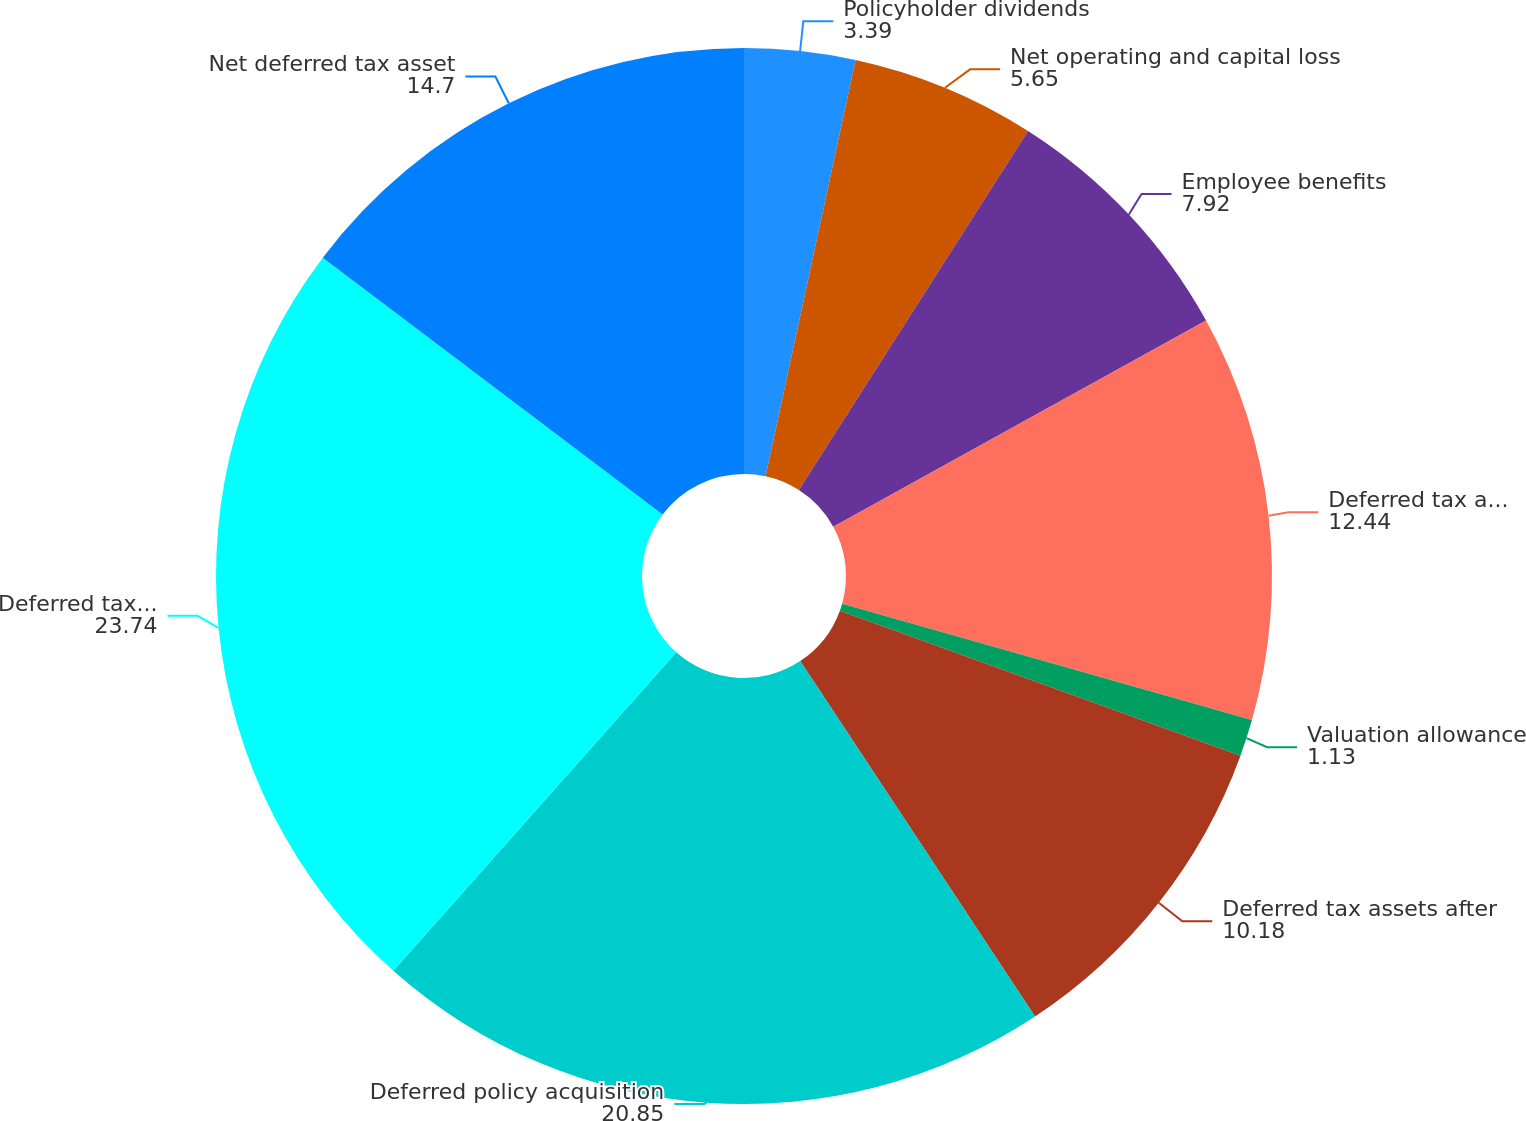Convert chart to OTSL. <chart><loc_0><loc_0><loc_500><loc_500><pie_chart><fcel>Policyholder dividends<fcel>Net operating and capital loss<fcel>Employee benefits<fcel>Deferred tax assets before<fcel>Valuation allowance<fcel>Deferred tax assets after<fcel>Deferred policy acquisition<fcel>Deferred tax liabilities<fcel>Net deferred tax asset<nl><fcel>3.39%<fcel>5.65%<fcel>7.92%<fcel>12.44%<fcel>1.13%<fcel>10.18%<fcel>20.85%<fcel>23.74%<fcel>14.7%<nl></chart> 